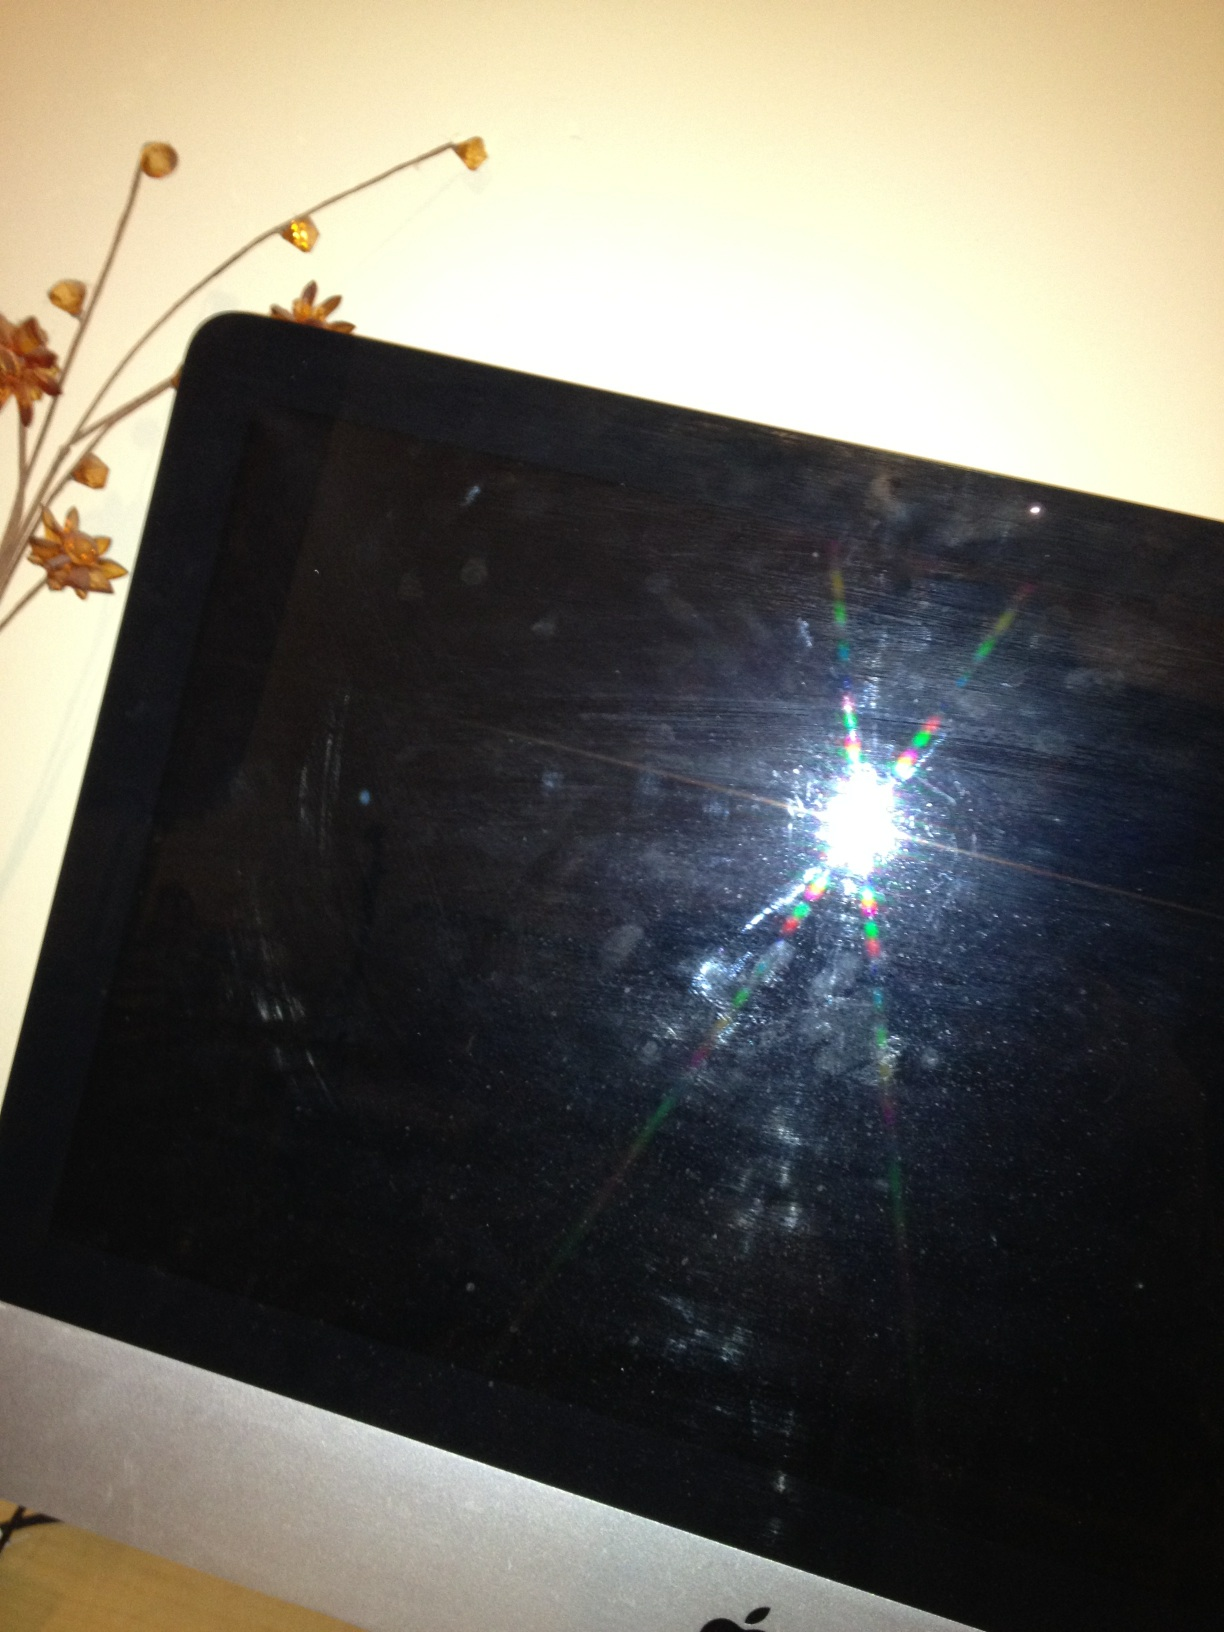Can you describe anything interesting in this image? The most interesting aspect of this image is the vibrant light reflection in the middle of the screen. It creates a multi-colored star-like effect, which stands out against the otherwise dark and matte surface of the screen. Does the reflection suggest anything about the surroundings or lighting? The reflection suggests that there is a bright light source nearby which is likely causing the star-like burst effect. This could be from artificial lighting such as a lamp or overhead light. The angle and intensity of the light suggest it's quite close to the screen. Imagine a fantasy world beyond this screen. What could it look like? Imagine a portal into a fantastical realm just through the screen. On the other side, there could be vast, endless landscapes filled with floating islands that defy gravity, lush forests that glow with bioluminescent flora, and skies painted in hues of purple and gold. Mighty dragons soar through the skies, and mystical creatures inhabit serene lakes and rivers that shimmer with magic. The air is filled with the sound of ancient melodies played by invisible musicians, creating an enchanting and surreal atmosphere. In a realistic scenario, what might be the most likely reason for the screen to be off? A realistic reason for the screen to be off could be that the device is in sleep or power-saving mode because it hasn't been used for a while. Another possibility could be that it has been turned off manually to save energy. 